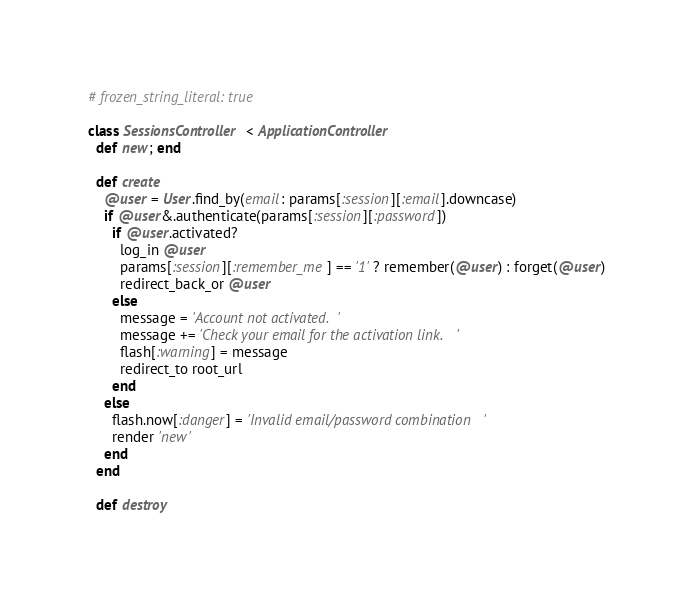Convert code to text. <code><loc_0><loc_0><loc_500><loc_500><_Ruby_># frozen_string_literal: true

class SessionsController < ApplicationController
  def new; end

  def create
    @user = User.find_by(email: params[:session][:email].downcase)
    if @user&.authenticate(params[:session][:password])
      if @user.activated?
        log_in @user
        params[:session][:remember_me] == '1' ? remember(@user) : forget(@user)
        redirect_back_or @user
      else
        message = 'Account not activated.'
        message += 'Check your email for the activation link.'
        flash[:warning] = message
        redirect_to root_url
      end
    else
      flash.now[:danger] = 'Invalid email/password combination'
      render 'new'
    end
  end

  def destroy</code> 